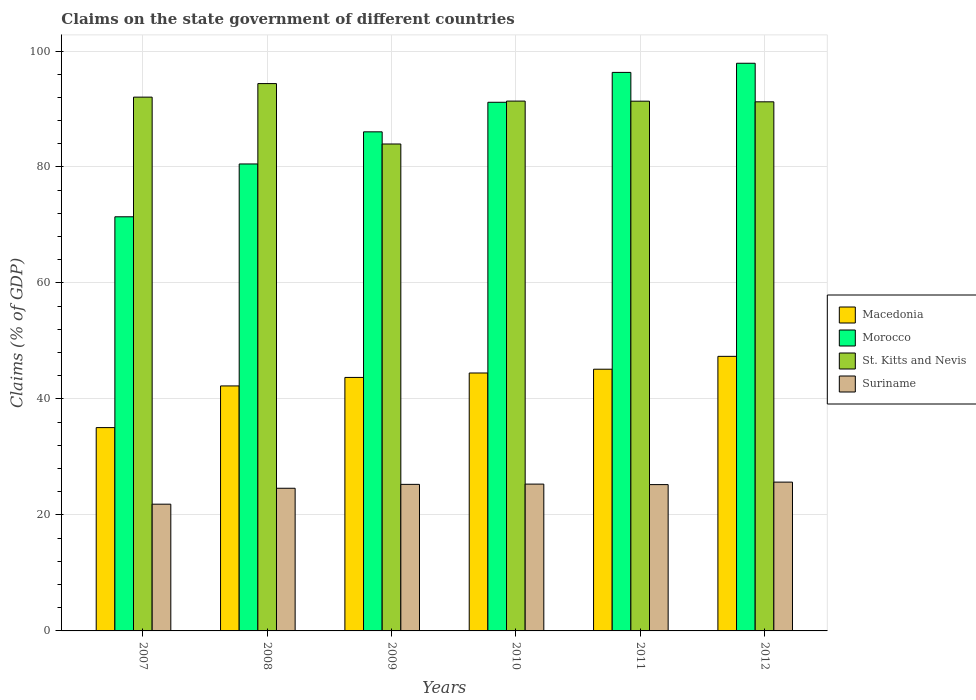How many different coloured bars are there?
Ensure brevity in your answer.  4. How many groups of bars are there?
Make the answer very short. 6. Are the number of bars per tick equal to the number of legend labels?
Offer a very short reply. Yes. Are the number of bars on each tick of the X-axis equal?
Provide a succinct answer. Yes. How many bars are there on the 3rd tick from the left?
Your response must be concise. 4. How many bars are there on the 3rd tick from the right?
Make the answer very short. 4. What is the label of the 2nd group of bars from the left?
Your answer should be compact. 2008. In how many cases, is the number of bars for a given year not equal to the number of legend labels?
Make the answer very short. 0. What is the percentage of GDP claimed on the state government in St. Kitts and Nevis in 2010?
Keep it short and to the point. 91.37. Across all years, what is the maximum percentage of GDP claimed on the state government in Morocco?
Give a very brief answer. 97.89. Across all years, what is the minimum percentage of GDP claimed on the state government in Suriname?
Provide a succinct answer. 21.85. In which year was the percentage of GDP claimed on the state government in Macedonia maximum?
Provide a short and direct response. 2012. In which year was the percentage of GDP claimed on the state government in Morocco minimum?
Keep it short and to the point. 2007. What is the total percentage of GDP claimed on the state government in Suriname in the graph?
Offer a very short reply. 147.93. What is the difference between the percentage of GDP claimed on the state government in St. Kitts and Nevis in 2007 and that in 2008?
Keep it short and to the point. -2.33. What is the difference between the percentage of GDP claimed on the state government in Macedonia in 2010 and the percentage of GDP claimed on the state government in Suriname in 2009?
Your response must be concise. 19.21. What is the average percentage of GDP claimed on the state government in Macedonia per year?
Provide a short and direct response. 43. In the year 2009, what is the difference between the percentage of GDP claimed on the state government in Morocco and percentage of GDP claimed on the state government in Macedonia?
Provide a succinct answer. 42.35. In how many years, is the percentage of GDP claimed on the state government in Macedonia greater than 44 %?
Ensure brevity in your answer.  3. What is the ratio of the percentage of GDP claimed on the state government in Suriname in 2010 to that in 2012?
Your answer should be very brief. 0.99. What is the difference between the highest and the second highest percentage of GDP claimed on the state government in Suriname?
Offer a very short reply. 0.34. What is the difference between the highest and the lowest percentage of GDP claimed on the state government in St. Kitts and Nevis?
Ensure brevity in your answer.  10.42. In how many years, is the percentage of GDP claimed on the state government in Suriname greater than the average percentage of GDP claimed on the state government in Suriname taken over all years?
Make the answer very short. 4. What does the 3rd bar from the left in 2007 represents?
Provide a succinct answer. St. Kitts and Nevis. What does the 2nd bar from the right in 2007 represents?
Make the answer very short. St. Kitts and Nevis. What is the difference between two consecutive major ticks on the Y-axis?
Your answer should be very brief. 20. Does the graph contain any zero values?
Keep it short and to the point. No. Does the graph contain grids?
Your response must be concise. Yes. Where does the legend appear in the graph?
Your response must be concise. Center right. How are the legend labels stacked?
Provide a short and direct response. Vertical. What is the title of the graph?
Make the answer very short. Claims on the state government of different countries. Does "Puerto Rico" appear as one of the legend labels in the graph?
Ensure brevity in your answer.  No. What is the label or title of the Y-axis?
Offer a terse response. Claims (% of GDP). What is the Claims (% of GDP) of Macedonia in 2007?
Provide a succinct answer. 35.06. What is the Claims (% of GDP) in Morocco in 2007?
Provide a short and direct response. 71.41. What is the Claims (% of GDP) of St. Kitts and Nevis in 2007?
Make the answer very short. 92.05. What is the Claims (% of GDP) of Suriname in 2007?
Your response must be concise. 21.85. What is the Claims (% of GDP) in Macedonia in 2008?
Offer a very short reply. 42.25. What is the Claims (% of GDP) of Morocco in 2008?
Your response must be concise. 80.52. What is the Claims (% of GDP) of St. Kitts and Nevis in 2008?
Make the answer very short. 94.38. What is the Claims (% of GDP) of Suriname in 2008?
Offer a terse response. 24.6. What is the Claims (% of GDP) in Macedonia in 2009?
Your answer should be very brief. 43.71. What is the Claims (% of GDP) in Morocco in 2009?
Your response must be concise. 86.06. What is the Claims (% of GDP) in St. Kitts and Nevis in 2009?
Offer a terse response. 83.97. What is the Claims (% of GDP) in Suriname in 2009?
Provide a short and direct response. 25.27. What is the Claims (% of GDP) in Macedonia in 2010?
Offer a very short reply. 44.48. What is the Claims (% of GDP) in Morocco in 2010?
Make the answer very short. 91.16. What is the Claims (% of GDP) of St. Kitts and Nevis in 2010?
Make the answer very short. 91.37. What is the Claims (% of GDP) in Suriname in 2010?
Provide a succinct answer. 25.32. What is the Claims (% of GDP) in Macedonia in 2011?
Provide a short and direct response. 45.13. What is the Claims (% of GDP) of Morocco in 2011?
Ensure brevity in your answer.  96.31. What is the Claims (% of GDP) of St. Kitts and Nevis in 2011?
Your answer should be compact. 91.35. What is the Claims (% of GDP) of Suriname in 2011?
Ensure brevity in your answer.  25.23. What is the Claims (% of GDP) of Macedonia in 2012?
Offer a very short reply. 47.35. What is the Claims (% of GDP) of Morocco in 2012?
Your answer should be compact. 97.89. What is the Claims (% of GDP) of St. Kitts and Nevis in 2012?
Offer a terse response. 91.24. What is the Claims (% of GDP) of Suriname in 2012?
Your answer should be compact. 25.66. Across all years, what is the maximum Claims (% of GDP) of Macedonia?
Your answer should be very brief. 47.35. Across all years, what is the maximum Claims (% of GDP) of Morocco?
Make the answer very short. 97.89. Across all years, what is the maximum Claims (% of GDP) in St. Kitts and Nevis?
Your response must be concise. 94.38. Across all years, what is the maximum Claims (% of GDP) in Suriname?
Make the answer very short. 25.66. Across all years, what is the minimum Claims (% of GDP) in Macedonia?
Offer a terse response. 35.06. Across all years, what is the minimum Claims (% of GDP) of Morocco?
Keep it short and to the point. 71.41. Across all years, what is the minimum Claims (% of GDP) in St. Kitts and Nevis?
Keep it short and to the point. 83.97. Across all years, what is the minimum Claims (% of GDP) in Suriname?
Offer a terse response. 21.85. What is the total Claims (% of GDP) of Macedonia in the graph?
Your response must be concise. 257.97. What is the total Claims (% of GDP) of Morocco in the graph?
Your answer should be very brief. 523.35. What is the total Claims (% of GDP) of St. Kitts and Nevis in the graph?
Provide a short and direct response. 544.34. What is the total Claims (% of GDP) in Suriname in the graph?
Make the answer very short. 147.93. What is the difference between the Claims (% of GDP) of Macedonia in 2007 and that in 2008?
Your answer should be compact. -7.19. What is the difference between the Claims (% of GDP) of Morocco in 2007 and that in 2008?
Make the answer very short. -9.11. What is the difference between the Claims (% of GDP) of St. Kitts and Nevis in 2007 and that in 2008?
Make the answer very short. -2.33. What is the difference between the Claims (% of GDP) in Suriname in 2007 and that in 2008?
Make the answer very short. -2.75. What is the difference between the Claims (% of GDP) in Macedonia in 2007 and that in 2009?
Keep it short and to the point. -8.65. What is the difference between the Claims (% of GDP) in Morocco in 2007 and that in 2009?
Ensure brevity in your answer.  -14.65. What is the difference between the Claims (% of GDP) in St. Kitts and Nevis in 2007 and that in 2009?
Keep it short and to the point. 8.08. What is the difference between the Claims (% of GDP) of Suriname in 2007 and that in 2009?
Offer a terse response. -3.42. What is the difference between the Claims (% of GDP) in Macedonia in 2007 and that in 2010?
Keep it short and to the point. -9.42. What is the difference between the Claims (% of GDP) of Morocco in 2007 and that in 2010?
Your answer should be very brief. -19.74. What is the difference between the Claims (% of GDP) of St. Kitts and Nevis in 2007 and that in 2010?
Offer a terse response. 0.68. What is the difference between the Claims (% of GDP) in Suriname in 2007 and that in 2010?
Provide a short and direct response. -3.46. What is the difference between the Claims (% of GDP) in Macedonia in 2007 and that in 2011?
Your response must be concise. -10.07. What is the difference between the Claims (% of GDP) of Morocco in 2007 and that in 2011?
Ensure brevity in your answer.  -24.9. What is the difference between the Claims (% of GDP) of St. Kitts and Nevis in 2007 and that in 2011?
Your answer should be very brief. 0.7. What is the difference between the Claims (% of GDP) of Suriname in 2007 and that in 2011?
Make the answer very short. -3.38. What is the difference between the Claims (% of GDP) in Macedonia in 2007 and that in 2012?
Your response must be concise. -12.29. What is the difference between the Claims (% of GDP) of Morocco in 2007 and that in 2012?
Make the answer very short. -26.47. What is the difference between the Claims (% of GDP) of St. Kitts and Nevis in 2007 and that in 2012?
Offer a terse response. 0.81. What is the difference between the Claims (% of GDP) in Suriname in 2007 and that in 2012?
Provide a short and direct response. -3.81. What is the difference between the Claims (% of GDP) of Macedonia in 2008 and that in 2009?
Keep it short and to the point. -1.46. What is the difference between the Claims (% of GDP) of Morocco in 2008 and that in 2009?
Your answer should be compact. -5.54. What is the difference between the Claims (% of GDP) of St. Kitts and Nevis in 2008 and that in 2009?
Offer a terse response. 10.42. What is the difference between the Claims (% of GDP) of Suriname in 2008 and that in 2009?
Your response must be concise. -0.67. What is the difference between the Claims (% of GDP) of Macedonia in 2008 and that in 2010?
Your response must be concise. -2.23. What is the difference between the Claims (% of GDP) in Morocco in 2008 and that in 2010?
Give a very brief answer. -10.64. What is the difference between the Claims (% of GDP) in St. Kitts and Nevis in 2008 and that in 2010?
Keep it short and to the point. 3.02. What is the difference between the Claims (% of GDP) in Suriname in 2008 and that in 2010?
Your answer should be compact. -0.72. What is the difference between the Claims (% of GDP) in Macedonia in 2008 and that in 2011?
Give a very brief answer. -2.88. What is the difference between the Claims (% of GDP) of Morocco in 2008 and that in 2011?
Your response must be concise. -15.79. What is the difference between the Claims (% of GDP) in St. Kitts and Nevis in 2008 and that in 2011?
Your answer should be very brief. 3.03. What is the difference between the Claims (% of GDP) in Suriname in 2008 and that in 2011?
Your answer should be compact. -0.63. What is the difference between the Claims (% of GDP) in Macedonia in 2008 and that in 2012?
Ensure brevity in your answer.  -5.1. What is the difference between the Claims (% of GDP) of Morocco in 2008 and that in 2012?
Ensure brevity in your answer.  -17.37. What is the difference between the Claims (% of GDP) in St. Kitts and Nevis in 2008 and that in 2012?
Keep it short and to the point. 3.14. What is the difference between the Claims (% of GDP) of Suriname in 2008 and that in 2012?
Your answer should be very brief. -1.06. What is the difference between the Claims (% of GDP) of Macedonia in 2009 and that in 2010?
Keep it short and to the point. -0.77. What is the difference between the Claims (% of GDP) of Morocco in 2009 and that in 2010?
Ensure brevity in your answer.  -5.1. What is the difference between the Claims (% of GDP) in St. Kitts and Nevis in 2009 and that in 2010?
Keep it short and to the point. -7.4. What is the difference between the Claims (% of GDP) of Suriname in 2009 and that in 2010?
Keep it short and to the point. -0.05. What is the difference between the Claims (% of GDP) of Macedonia in 2009 and that in 2011?
Ensure brevity in your answer.  -1.42. What is the difference between the Claims (% of GDP) of Morocco in 2009 and that in 2011?
Give a very brief answer. -10.25. What is the difference between the Claims (% of GDP) in St. Kitts and Nevis in 2009 and that in 2011?
Ensure brevity in your answer.  -7.38. What is the difference between the Claims (% of GDP) in Suriname in 2009 and that in 2011?
Provide a succinct answer. 0.04. What is the difference between the Claims (% of GDP) in Macedonia in 2009 and that in 2012?
Provide a short and direct response. -3.64. What is the difference between the Claims (% of GDP) of Morocco in 2009 and that in 2012?
Your answer should be compact. -11.83. What is the difference between the Claims (% of GDP) of St. Kitts and Nevis in 2009 and that in 2012?
Provide a short and direct response. -7.27. What is the difference between the Claims (% of GDP) in Suriname in 2009 and that in 2012?
Your response must be concise. -0.39. What is the difference between the Claims (% of GDP) in Macedonia in 2010 and that in 2011?
Provide a succinct answer. -0.65. What is the difference between the Claims (% of GDP) in Morocco in 2010 and that in 2011?
Provide a short and direct response. -5.15. What is the difference between the Claims (% of GDP) of St. Kitts and Nevis in 2010 and that in 2011?
Provide a short and direct response. 0.02. What is the difference between the Claims (% of GDP) in Suriname in 2010 and that in 2011?
Make the answer very short. 0.09. What is the difference between the Claims (% of GDP) in Macedonia in 2010 and that in 2012?
Your answer should be very brief. -2.87. What is the difference between the Claims (% of GDP) of Morocco in 2010 and that in 2012?
Keep it short and to the point. -6.73. What is the difference between the Claims (% of GDP) of St. Kitts and Nevis in 2010 and that in 2012?
Provide a succinct answer. 0.13. What is the difference between the Claims (% of GDP) of Suriname in 2010 and that in 2012?
Provide a succinct answer. -0.34. What is the difference between the Claims (% of GDP) in Macedonia in 2011 and that in 2012?
Your response must be concise. -2.22. What is the difference between the Claims (% of GDP) of Morocco in 2011 and that in 2012?
Your answer should be very brief. -1.58. What is the difference between the Claims (% of GDP) in St. Kitts and Nevis in 2011 and that in 2012?
Make the answer very short. 0.11. What is the difference between the Claims (% of GDP) of Suriname in 2011 and that in 2012?
Your answer should be very brief. -0.43. What is the difference between the Claims (% of GDP) of Macedonia in 2007 and the Claims (% of GDP) of Morocco in 2008?
Give a very brief answer. -45.46. What is the difference between the Claims (% of GDP) in Macedonia in 2007 and the Claims (% of GDP) in St. Kitts and Nevis in 2008?
Offer a terse response. -59.32. What is the difference between the Claims (% of GDP) of Macedonia in 2007 and the Claims (% of GDP) of Suriname in 2008?
Make the answer very short. 10.46. What is the difference between the Claims (% of GDP) in Morocco in 2007 and the Claims (% of GDP) in St. Kitts and Nevis in 2008?
Your answer should be very brief. -22.97. What is the difference between the Claims (% of GDP) in Morocco in 2007 and the Claims (% of GDP) in Suriname in 2008?
Offer a very short reply. 46.81. What is the difference between the Claims (% of GDP) in St. Kitts and Nevis in 2007 and the Claims (% of GDP) in Suriname in 2008?
Ensure brevity in your answer.  67.44. What is the difference between the Claims (% of GDP) in Macedonia in 2007 and the Claims (% of GDP) in Morocco in 2009?
Offer a very short reply. -51. What is the difference between the Claims (% of GDP) in Macedonia in 2007 and the Claims (% of GDP) in St. Kitts and Nevis in 2009?
Give a very brief answer. -48.91. What is the difference between the Claims (% of GDP) in Macedonia in 2007 and the Claims (% of GDP) in Suriname in 2009?
Your answer should be very brief. 9.79. What is the difference between the Claims (% of GDP) of Morocco in 2007 and the Claims (% of GDP) of St. Kitts and Nevis in 2009?
Your answer should be very brief. -12.55. What is the difference between the Claims (% of GDP) of Morocco in 2007 and the Claims (% of GDP) of Suriname in 2009?
Make the answer very short. 46.14. What is the difference between the Claims (% of GDP) in St. Kitts and Nevis in 2007 and the Claims (% of GDP) in Suriname in 2009?
Offer a very short reply. 66.78. What is the difference between the Claims (% of GDP) of Macedonia in 2007 and the Claims (% of GDP) of Morocco in 2010?
Offer a very short reply. -56.1. What is the difference between the Claims (% of GDP) of Macedonia in 2007 and the Claims (% of GDP) of St. Kitts and Nevis in 2010?
Keep it short and to the point. -56.3. What is the difference between the Claims (% of GDP) of Macedonia in 2007 and the Claims (% of GDP) of Suriname in 2010?
Provide a short and direct response. 9.74. What is the difference between the Claims (% of GDP) in Morocco in 2007 and the Claims (% of GDP) in St. Kitts and Nevis in 2010?
Provide a short and direct response. -19.95. What is the difference between the Claims (% of GDP) in Morocco in 2007 and the Claims (% of GDP) in Suriname in 2010?
Keep it short and to the point. 46.1. What is the difference between the Claims (% of GDP) of St. Kitts and Nevis in 2007 and the Claims (% of GDP) of Suriname in 2010?
Keep it short and to the point. 66.73. What is the difference between the Claims (% of GDP) of Macedonia in 2007 and the Claims (% of GDP) of Morocco in 2011?
Your answer should be compact. -61.25. What is the difference between the Claims (% of GDP) of Macedonia in 2007 and the Claims (% of GDP) of St. Kitts and Nevis in 2011?
Your response must be concise. -56.29. What is the difference between the Claims (% of GDP) in Macedonia in 2007 and the Claims (% of GDP) in Suriname in 2011?
Provide a succinct answer. 9.83. What is the difference between the Claims (% of GDP) of Morocco in 2007 and the Claims (% of GDP) of St. Kitts and Nevis in 2011?
Your answer should be compact. -19.93. What is the difference between the Claims (% of GDP) in Morocco in 2007 and the Claims (% of GDP) in Suriname in 2011?
Keep it short and to the point. 46.18. What is the difference between the Claims (% of GDP) in St. Kitts and Nevis in 2007 and the Claims (% of GDP) in Suriname in 2011?
Offer a very short reply. 66.82. What is the difference between the Claims (% of GDP) of Macedonia in 2007 and the Claims (% of GDP) of Morocco in 2012?
Provide a short and direct response. -62.83. What is the difference between the Claims (% of GDP) in Macedonia in 2007 and the Claims (% of GDP) in St. Kitts and Nevis in 2012?
Your answer should be compact. -56.18. What is the difference between the Claims (% of GDP) in Macedonia in 2007 and the Claims (% of GDP) in Suriname in 2012?
Provide a short and direct response. 9.4. What is the difference between the Claims (% of GDP) of Morocco in 2007 and the Claims (% of GDP) of St. Kitts and Nevis in 2012?
Your answer should be compact. -19.82. What is the difference between the Claims (% of GDP) in Morocco in 2007 and the Claims (% of GDP) in Suriname in 2012?
Your answer should be very brief. 45.75. What is the difference between the Claims (% of GDP) of St. Kitts and Nevis in 2007 and the Claims (% of GDP) of Suriname in 2012?
Your answer should be very brief. 66.39. What is the difference between the Claims (% of GDP) of Macedonia in 2008 and the Claims (% of GDP) of Morocco in 2009?
Make the answer very short. -43.81. What is the difference between the Claims (% of GDP) in Macedonia in 2008 and the Claims (% of GDP) in St. Kitts and Nevis in 2009?
Your answer should be compact. -41.72. What is the difference between the Claims (% of GDP) in Macedonia in 2008 and the Claims (% of GDP) in Suriname in 2009?
Your response must be concise. 16.98. What is the difference between the Claims (% of GDP) of Morocco in 2008 and the Claims (% of GDP) of St. Kitts and Nevis in 2009?
Provide a short and direct response. -3.45. What is the difference between the Claims (% of GDP) of Morocco in 2008 and the Claims (% of GDP) of Suriname in 2009?
Offer a very short reply. 55.25. What is the difference between the Claims (% of GDP) of St. Kitts and Nevis in 2008 and the Claims (% of GDP) of Suriname in 2009?
Ensure brevity in your answer.  69.11. What is the difference between the Claims (% of GDP) in Macedonia in 2008 and the Claims (% of GDP) in Morocco in 2010?
Make the answer very short. -48.91. What is the difference between the Claims (% of GDP) in Macedonia in 2008 and the Claims (% of GDP) in St. Kitts and Nevis in 2010?
Provide a succinct answer. -49.12. What is the difference between the Claims (% of GDP) in Macedonia in 2008 and the Claims (% of GDP) in Suriname in 2010?
Offer a very short reply. 16.93. What is the difference between the Claims (% of GDP) of Morocco in 2008 and the Claims (% of GDP) of St. Kitts and Nevis in 2010?
Offer a terse response. -10.84. What is the difference between the Claims (% of GDP) in Morocco in 2008 and the Claims (% of GDP) in Suriname in 2010?
Give a very brief answer. 55.2. What is the difference between the Claims (% of GDP) of St. Kitts and Nevis in 2008 and the Claims (% of GDP) of Suriname in 2010?
Your response must be concise. 69.06. What is the difference between the Claims (% of GDP) in Macedonia in 2008 and the Claims (% of GDP) in Morocco in 2011?
Make the answer very short. -54.06. What is the difference between the Claims (% of GDP) of Macedonia in 2008 and the Claims (% of GDP) of St. Kitts and Nevis in 2011?
Your answer should be compact. -49.1. What is the difference between the Claims (% of GDP) of Macedonia in 2008 and the Claims (% of GDP) of Suriname in 2011?
Offer a terse response. 17.02. What is the difference between the Claims (% of GDP) in Morocco in 2008 and the Claims (% of GDP) in St. Kitts and Nevis in 2011?
Give a very brief answer. -10.83. What is the difference between the Claims (% of GDP) in Morocco in 2008 and the Claims (% of GDP) in Suriname in 2011?
Make the answer very short. 55.29. What is the difference between the Claims (% of GDP) of St. Kitts and Nevis in 2008 and the Claims (% of GDP) of Suriname in 2011?
Your answer should be very brief. 69.15. What is the difference between the Claims (% of GDP) in Macedonia in 2008 and the Claims (% of GDP) in Morocco in 2012?
Keep it short and to the point. -55.64. What is the difference between the Claims (% of GDP) of Macedonia in 2008 and the Claims (% of GDP) of St. Kitts and Nevis in 2012?
Your response must be concise. -48.99. What is the difference between the Claims (% of GDP) of Macedonia in 2008 and the Claims (% of GDP) of Suriname in 2012?
Provide a succinct answer. 16.59. What is the difference between the Claims (% of GDP) of Morocco in 2008 and the Claims (% of GDP) of St. Kitts and Nevis in 2012?
Ensure brevity in your answer.  -10.72. What is the difference between the Claims (% of GDP) of Morocco in 2008 and the Claims (% of GDP) of Suriname in 2012?
Offer a terse response. 54.86. What is the difference between the Claims (% of GDP) in St. Kitts and Nevis in 2008 and the Claims (% of GDP) in Suriname in 2012?
Your response must be concise. 68.72. What is the difference between the Claims (% of GDP) in Macedonia in 2009 and the Claims (% of GDP) in Morocco in 2010?
Offer a terse response. -47.45. What is the difference between the Claims (% of GDP) of Macedonia in 2009 and the Claims (% of GDP) of St. Kitts and Nevis in 2010?
Keep it short and to the point. -47.65. What is the difference between the Claims (% of GDP) of Macedonia in 2009 and the Claims (% of GDP) of Suriname in 2010?
Give a very brief answer. 18.39. What is the difference between the Claims (% of GDP) in Morocco in 2009 and the Claims (% of GDP) in St. Kitts and Nevis in 2010?
Your answer should be very brief. -5.3. What is the difference between the Claims (% of GDP) in Morocco in 2009 and the Claims (% of GDP) in Suriname in 2010?
Give a very brief answer. 60.74. What is the difference between the Claims (% of GDP) of St. Kitts and Nevis in 2009 and the Claims (% of GDP) of Suriname in 2010?
Your answer should be compact. 58.65. What is the difference between the Claims (% of GDP) of Macedonia in 2009 and the Claims (% of GDP) of Morocco in 2011?
Provide a succinct answer. -52.6. What is the difference between the Claims (% of GDP) in Macedonia in 2009 and the Claims (% of GDP) in St. Kitts and Nevis in 2011?
Ensure brevity in your answer.  -47.64. What is the difference between the Claims (% of GDP) of Macedonia in 2009 and the Claims (% of GDP) of Suriname in 2011?
Your answer should be compact. 18.48. What is the difference between the Claims (% of GDP) of Morocco in 2009 and the Claims (% of GDP) of St. Kitts and Nevis in 2011?
Keep it short and to the point. -5.29. What is the difference between the Claims (% of GDP) in Morocco in 2009 and the Claims (% of GDP) in Suriname in 2011?
Give a very brief answer. 60.83. What is the difference between the Claims (% of GDP) in St. Kitts and Nevis in 2009 and the Claims (% of GDP) in Suriname in 2011?
Ensure brevity in your answer.  58.73. What is the difference between the Claims (% of GDP) of Macedonia in 2009 and the Claims (% of GDP) of Morocco in 2012?
Offer a terse response. -54.18. What is the difference between the Claims (% of GDP) in Macedonia in 2009 and the Claims (% of GDP) in St. Kitts and Nevis in 2012?
Make the answer very short. -47.53. What is the difference between the Claims (% of GDP) of Macedonia in 2009 and the Claims (% of GDP) of Suriname in 2012?
Ensure brevity in your answer.  18.05. What is the difference between the Claims (% of GDP) of Morocco in 2009 and the Claims (% of GDP) of St. Kitts and Nevis in 2012?
Keep it short and to the point. -5.18. What is the difference between the Claims (% of GDP) in Morocco in 2009 and the Claims (% of GDP) in Suriname in 2012?
Provide a succinct answer. 60.4. What is the difference between the Claims (% of GDP) of St. Kitts and Nevis in 2009 and the Claims (% of GDP) of Suriname in 2012?
Give a very brief answer. 58.31. What is the difference between the Claims (% of GDP) of Macedonia in 2010 and the Claims (% of GDP) of Morocco in 2011?
Provide a succinct answer. -51.83. What is the difference between the Claims (% of GDP) in Macedonia in 2010 and the Claims (% of GDP) in St. Kitts and Nevis in 2011?
Your answer should be very brief. -46.87. What is the difference between the Claims (% of GDP) in Macedonia in 2010 and the Claims (% of GDP) in Suriname in 2011?
Your answer should be compact. 19.25. What is the difference between the Claims (% of GDP) in Morocco in 2010 and the Claims (% of GDP) in St. Kitts and Nevis in 2011?
Ensure brevity in your answer.  -0.19. What is the difference between the Claims (% of GDP) in Morocco in 2010 and the Claims (% of GDP) in Suriname in 2011?
Give a very brief answer. 65.93. What is the difference between the Claims (% of GDP) in St. Kitts and Nevis in 2010 and the Claims (% of GDP) in Suriname in 2011?
Offer a terse response. 66.13. What is the difference between the Claims (% of GDP) of Macedonia in 2010 and the Claims (% of GDP) of Morocco in 2012?
Give a very brief answer. -53.41. What is the difference between the Claims (% of GDP) in Macedonia in 2010 and the Claims (% of GDP) in St. Kitts and Nevis in 2012?
Your answer should be very brief. -46.76. What is the difference between the Claims (% of GDP) of Macedonia in 2010 and the Claims (% of GDP) of Suriname in 2012?
Your response must be concise. 18.82. What is the difference between the Claims (% of GDP) of Morocco in 2010 and the Claims (% of GDP) of St. Kitts and Nevis in 2012?
Offer a very short reply. -0.08. What is the difference between the Claims (% of GDP) of Morocco in 2010 and the Claims (% of GDP) of Suriname in 2012?
Your answer should be compact. 65.5. What is the difference between the Claims (% of GDP) of St. Kitts and Nevis in 2010 and the Claims (% of GDP) of Suriname in 2012?
Ensure brevity in your answer.  65.71. What is the difference between the Claims (% of GDP) of Macedonia in 2011 and the Claims (% of GDP) of Morocco in 2012?
Your answer should be compact. -52.76. What is the difference between the Claims (% of GDP) of Macedonia in 2011 and the Claims (% of GDP) of St. Kitts and Nevis in 2012?
Give a very brief answer. -46.11. What is the difference between the Claims (% of GDP) of Macedonia in 2011 and the Claims (% of GDP) of Suriname in 2012?
Provide a short and direct response. 19.47. What is the difference between the Claims (% of GDP) in Morocco in 2011 and the Claims (% of GDP) in St. Kitts and Nevis in 2012?
Provide a succinct answer. 5.07. What is the difference between the Claims (% of GDP) of Morocco in 2011 and the Claims (% of GDP) of Suriname in 2012?
Keep it short and to the point. 70.65. What is the difference between the Claims (% of GDP) of St. Kitts and Nevis in 2011 and the Claims (% of GDP) of Suriname in 2012?
Keep it short and to the point. 65.69. What is the average Claims (% of GDP) in Macedonia per year?
Provide a short and direct response. 43. What is the average Claims (% of GDP) in Morocco per year?
Offer a terse response. 87.23. What is the average Claims (% of GDP) of St. Kitts and Nevis per year?
Ensure brevity in your answer.  90.72. What is the average Claims (% of GDP) of Suriname per year?
Offer a terse response. 24.66. In the year 2007, what is the difference between the Claims (% of GDP) in Macedonia and Claims (% of GDP) in Morocco?
Make the answer very short. -36.35. In the year 2007, what is the difference between the Claims (% of GDP) in Macedonia and Claims (% of GDP) in St. Kitts and Nevis?
Provide a short and direct response. -56.99. In the year 2007, what is the difference between the Claims (% of GDP) of Macedonia and Claims (% of GDP) of Suriname?
Make the answer very short. 13.21. In the year 2007, what is the difference between the Claims (% of GDP) in Morocco and Claims (% of GDP) in St. Kitts and Nevis?
Give a very brief answer. -20.63. In the year 2007, what is the difference between the Claims (% of GDP) in Morocco and Claims (% of GDP) in Suriname?
Keep it short and to the point. 49.56. In the year 2007, what is the difference between the Claims (% of GDP) in St. Kitts and Nevis and Claims (% of GDP) in Suriname?
Provide a short and direct response. 70.19. In the year 2008, what is the difference between the Claims (% of GDP) of Macedonia and Claims (% of GDP) of Morocco?
Ensure brevity in your answer.  -38.27. In the year 2008, what is the difference between the Claims (% of GDP) in Macedonia and Claims (% of GDP) in St. Kitts and Nevis?
Keep it short and to the point. -52.13. In the year 2008, what is the difference between the Claims (% of GDP) of Macedonia and Claims (% of GDP) of Suriname?
Give a very brief answer. 17.65. In the year 2008, what is the difference between the Claims (% of GDP) of Morocco and Claims (% of GDP) of St. Kitts and Nevis?
Your response must be concise. -13.86. In the year 2008, what is the difference between the Claims (% of GDP) in Morocco and Claims (% of GDP) in Suriname?
Your answer should be very brief. 55.92. In the year 2008, what is the difference between the Claims (% of GDP) of St. Kitts and Nevis and Claims (% of GDP) of Suriname?
Give a very brief answer. 69.78. In the year 2009, what is the difference between the Claims (% of GDP) in Macedonia and Claims (% of GDP) in Morocco?
Give a very brief answer. -42.35. In the year 2009, what is the difference between the Claims (% of GDP) of Macedonia and Claims (% of GDP) of St. Kitts and Nevis?
Keep it short and to the point. -40.26. In the year 2009, what is the difference between the Claims (% of GDP) of Macedonia and Claims (% of GDP) of Suriname?
Ensure brevity in your answer.  18.44. In the year 2009, what is the difference between the Claims (% of GDP) of Morocco and Claims (% of GDP) of St. Kitts and Nevis?
Ensure brevity in your answer.  2.1. In the year 2009, what is the difference between the Claims (% of GDP) in Morocco and Claims (% of GDP) in Suriname?
Your answer should be compact. 60.79. In the year 2009, what is the difference between the Claims (% of GDP) of St. Kitts and Nevis and Claims (% of GDP) of Suriname?
Offer a very short reply. 58.7. In the year 2010, what is the difference between the Claims (% of GDP) of Macedonia and Claims (% of GDP) of Morocco?
Keep it short and to the point. -46.68. In the year 2010, what is the difference between the Claims (% of GDP) in Macedonia and Claims (% of GDP) in St. Kitts and Nevis?
Offer a terse response. -46.89. In the year 2010, what is the difference between the Claims (% of GDP) of Macedonia and Claims (% of GDP) of Suriname?
Make the answer very short. 19.16. In the year 2010, what is the difference between the Claims (% of GDP) in Morocco and Claims (% of GDP) in St. Kitts and Nevis?
Ensure brevity in your answer.  -0.21. In the year 2010, what is the difference between the Claims (% of GDP) in Morocco and Claims (% of GDP) in Suriname?
Your response must be concise. 65.84. In the year 2010, what is the difference between the Claims (% of GDP) in St. Kitts and Nevis and Claims (% of GDP) in Suriname?
Provide a short and direct response. 66.05. In the year 2011, what is the difference between the Claims (% of GDP) of Macedonia and Claims (% of GDP) of Morocco?
Keep it short and to the point. -51.18. In the year 2011, what is the difference between the Claims (% of GDP) in Macedonia and Claims (% of GDP) in St. Kitts and Nevis?
Offer a very short reply. -46.22. In the year 2011, what is the difference between the Claims (% of GDP) of Macedonia and Claims (% of GDP) of Suriname?
Offer a terse response. 19.9. In the year 2011, what is the difference between the Claims (% of GDP) in Morocco and Claims (% of GDP) in St. Kitts and Nevis?
Give a very brief answer. 4.96. In the year 2011, what is the difference between the Claims (% of GDP) of Morocco and Claims (% of GDP) of Suriname?
Give a very brief answer. 71.08. In the year 2011, what is the difference between the Claims (% of GDP) in St. Kitts and Nevis and Claims (% of GDP) in Suriname?
Offer a terse response. 66.12. In the year 2012, what is the difference between the Claims (% of GDP) of Macedonia and Claims (% of GDP) of Morocco?
Your answer should be very brief. -50.54. In the year 2012, what is the difference between the Claims (% of GDP) in Macedonia and Claims (% of GDP) in St. Kitts and Nevis?
Give a very brief answer. -43.89. In the year 2012, what is the difference between the Claims (% of GDP) of Macedonia and Claims (% of GDP) of Suriname?
Offer a terse response. 21.69. In the year 2012, what is the difference between the Claims (% of GDP) in Morocco and Claims (% of GDP) in St. Kitts and Nevis?
Your answer should be very brief. 6.65. In the year 2012, what is the difference between the Claims (% of GDP) of Morocco and Claims (% of GDP) of Suriname?
Keep it short and to the point. 72.23. In the year 2012, what is the difference between the Claims (% of GDP) of St. Kitts and Nevis and Claims (% of GDP) of Suriname?
Ensure brevity in your answer.  65.58. What is the ratio of the Claims (% of GDP) of Macedonia in 2007 to that in 2008?
Offer a terse response. 0.83. What is the ratio of the Claims (% of GDP) in Morocco in 2007 to that in 2008?
Offer a very short reply. 0.89. What is the ratio of the Claims (% of GDP) of St. Kitts and Nevis in 2007 to that in 2008?
Your response must be concise. 0.98. What is the ratio of the Claims (% of GDP) in Suriname in 2007 to that in 2008?
Your answer should be very brief. 0.89. What is the ratio of the Claims (% of GDP) in Macedonia in 2007 to that in 2009?
Your answer should be very brief. 0.8. What is the ratio of the Claims (% of GDP) in Morocco in 2007 to that in 2009?
Keep it short and to the point. 0.83. What is the ratio of the Claims (% of GDP) of St. Kitts and Nevis in 2007 to that in 2009?
Offer a terse response. 1.1. What is the ratio of the Claims (% of GDP) in Suriname in 2007 to that in 2009?
Your answer should be compact. 0.86. What is the ratio of the Claims (% of GDP) in Macedonia in 2007 to that in 2010?
Give a very brief answer. 0.79. What is the ratio of the Claims (% of GDP) in Morocco in 2007 to that in 2010?
Keep it short and to the point. 0.78. What is the ratio of the Claims (% of GDP) in St. Kitts and Nevis in 2007 to that in 2010?
Ensure brevity in your answer.  1.01. What is the ratio of the Claims (% of GDP) of Suriname in 2007 to that in 2010?
Provide a short and direct response. 0.86. What is the ratio of the Claims (% of GDP) in Macedonia in 2007 to that in 2011?
Ensure brevity in your answer.  0.78. What is the ratio of the Claims (% of GDP) of Morocco in 2007 to that in 2011?
Provide a short and direct response. 0.74. What is the ratio of the Claims (% of GDP) in St. Kitts and Nevis in 2007 to that in 2011?
Provide a succinct answer. 1.01. What is the ratio of the Claims (% of GDP) in Suriname in 2007 to that in 2011?
Ensure brevity in your answer.  0.87. What is the ratio of the Claims (% of GDP) in Macedonia in 2007 to that in 2012?
Your answer should be compact. 0.74. What is the ratio of the Claims (% of GDP) of Morocco in 2007 to that in 2012?
Ensure brevity in your answer.  0.73. What is the ratio of the Claims (% of GDP) in St. Kitts and Nevis in 2007 to that in 2012?
Ensure brevity in your answer.  1.01. What is the ratio of the Claims (% of GDP) in Suriname in 2007 to that in 2012?
Give a very brief answer. 0.85. What is the ratio of the Claims (% of GDP) of Macedonia in 2008 to that in 2009?
Provide a succinct answer. 0.97. What is the ratio of the Claims (% of GDP) in Morocco in 2008 to that in 2009?
Offer a very short reply. 0.94. What is the ratio of the Claims (% of GDP) in St. Kitts and Nevis in 2008 to that in 2009?
Your response must be concise. 1.12. What is the ratio of the Claims (% of GDP) of Suriname in 2008 to that in 2009?
Provide a short and direct response. 0.97. What is the ratio of the Claims (% of GDP) of Macedonia in 2008 to that in 2010?
Give a very brief answer. 0.95. What is the ratio of the Claims (% of GDP) of Morocco in 2008 to that in 2010?
Offer a very short reply. 0.88. What is the ratio of the Claims (% of GDP) of St. Kitts and Nevis in 2008 to that in 2010?
Make the answer very short. 1.03. What is the ratio of the Claims (% of GDP) in Suriname in 2008 to that in 2010?
Your answer should be very brief. 0.97. What is the ratio of the Claims (% of GDP) in Macedonia in 2008 to that in 2011?
Provide a succinct answer. 0.94. What is the ratio of the Claims (% of GDP) of Morocco in 2008 to that in 2011?
Your answer should be compact. 0.84. What is the ratio of the Claims (% of GDP) in St. Kitts and Nevis in 2008 to that in 2011?
Your answer should be very brief. 1.03. What is the ratio of the Claims (% of GDP) in Suriname in 2008 to that in 2011?
Ensure brevity in your answer.  0.98. What is the ratio of the Claims (% of GDP) in Macedonia in 2008 to that in 2012?
Give a very brief answer. 0.89. What is the ratio of the Claims (% of GDP) in Morocco in 2008 to that in 2012?
Offer a terse response. 0.82. What is the ratio of the Claims (% of GDP) of St. Kitts and Nevis in 2008 to that in 2012?
Make the answer very short. 1.03. What is the ratio of the Claims (% of GDP) in Suriname in 2008 to that in 2012?
Your response must be concise. 0.96. What is the ratio of the Claims (% of GDP) of Macedonia in 2009 to that in 2010?
Your answer should be very brief. 0.98. What is the ratio of the Claims (% of GDP) of Morocco in 2009 to that in 2010?
Your answer should be compact. 0.94. What is the ratio of the Claims (% of GDP) of St. Kitts and Nevis in 2009 to that in 2010?
Give a very brief answer. 0.92. What is the ratio of the Claims (% of GDP) in Macedonia in 2009 to that in 2011?
Ensure brevity in your answer.  0.97. What is the ratio of the Claims (% of GDP) in Morocco in 2009 to that in 2011?
Provide a short and direct response. 0.89. What is the ratio of the Claims (% of GDP) in St. Kitts and Nevis in 2009 to that in 2011?
Provide a short and direct response. 0.92. What is the ratio of the Claims (% of GDP) in Suriname in 2009 to that in 2011?
Your answer should be compact. 1. What is the ratio of the Claims (% of GDP) in Macedonia in 2009 to that in 2012?
Provide a succinct answer. 0.92. What is the ratio of the Claims (% of GDP) in Morocco in 2009 to that in 2012?
Make the answer very short. 0.88. What is the ratio of the Claims (% of GDP) in St. Kitts and Nevis in 2009 to that in 2012?
Your answer should be compact. 0.92. What is the ratio of the Claims (% of GDP) of Suriname in 2009 to that in 2012?
Ensure brevity in your answer.  0.98. What is the ratio of the Claims (% of GDP) in Macedonia in 2010 to that in 2011?
Offer a very short reply. 0.99. What is the ratio of the Claims (% of GDP) in Morocco in 2010 to that in 2011?
Your response must be concise. 0.95. What is the ratio of the Claims (% of GDP) in St. Kitts and Nevis in 2010 to that in 2011?
Provide a short and direct response. 1. What is the ratio of the Claims (% of GDP) of Macedonia in 2010 to that in 2012?
Your answer should be compact. 0.94. What is the ratio of the Claims (% of GDP) of Morocco in 2010 to that in 2012?
Your answer should be compact. 0.93. What is the ratio of the Claims (% of GDP) of St. Kitts and Nevis in 2010 to that in 2012?
Make the answer very short. 1. What is the ratio of the Claims (% of GDP) of Suriname in 2010 to that in 2012?
Offer a terse response. 0.99. What is the ratio of the Claims (% of GDP) in Macedonia in 2011 to that in 2012?
Your response must be concise. 0.95. What is the ratio of the Claims (% of GDP) in Morocco in 2011 to that in 2012?
Your answer should be very brief. 0.98. What is the ratio of the Claims (% of GDP) in Suriname in 2011 to that in 2012?
Keep it short and to the point. 0.98. What is the difference between the highest and the second highest Claims (% of GDP) of Macedonia?
Give a very brief answer. 2.22. What is the difference between the highest and the second highest Claims (% of GDP) in Morocco?
Your response must be concise. 1.58. What is the difference between the highest and the second highest Claims (% of GDP) in St. Kitts and Nevis?
Your answer should be very brief. 2.33. What is the difference between the highest and the second highest Claims (% of GDP) of Suriname?
Your response must be concise. 0.34. What is the difference between the highest and the lowest Claims (% of GDP) in Macedonia?
Offer a very short reply. 12.29. What is the difference between the highest and the lowest Claims (% of GDP) of Morocco?
Your answer should be compact. 26.47. What is the difference between the highest and the lowest Claims (% of GDP) in St. Kitts and Nevis?
Ensure brevity in your answer.  10.42. What is the difference between the highest and the lowest Claims (% of GDP) of Suriname?
Ensure brevity in your answer.  3.81. 